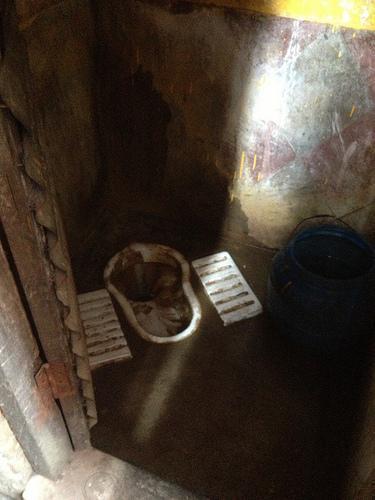How many lines are on a rectangle that is flanking the toilet?
Give a very brief answer. 6. How many hinges do you see?
Give a very brief answer. 1. 